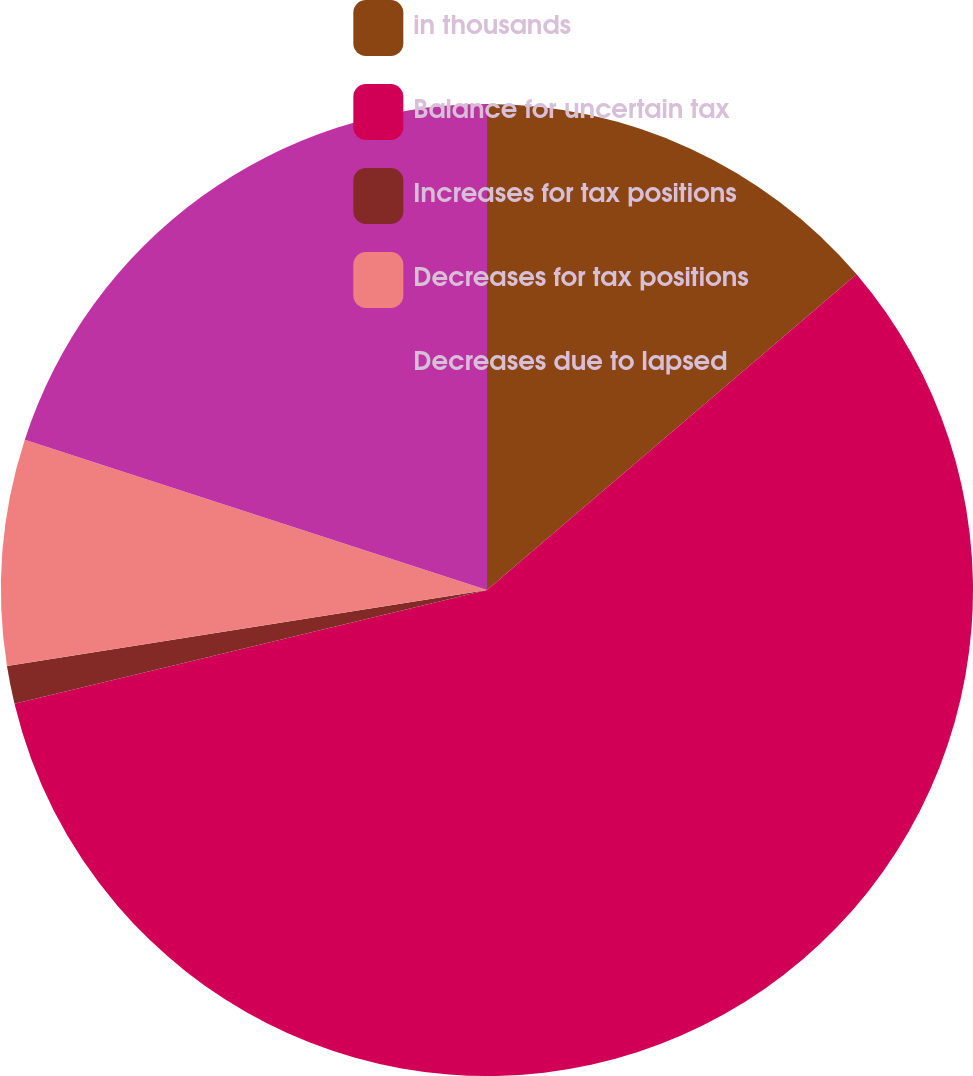Convert chart. <chart><loc_0><loc_0><loc_500><loc_500><pie_chart><fcel>in thousands<fcel>Balance for uncertain tax<fcel>Increases for tax positions<fcel>Decreases for tax positions<fcel>Decreases due to lapsed<nl><fcel>13.75%<fcel>57.49%<fcel>1.26%<fcel>7.5%<fcel>20.0%<nl></chart> 